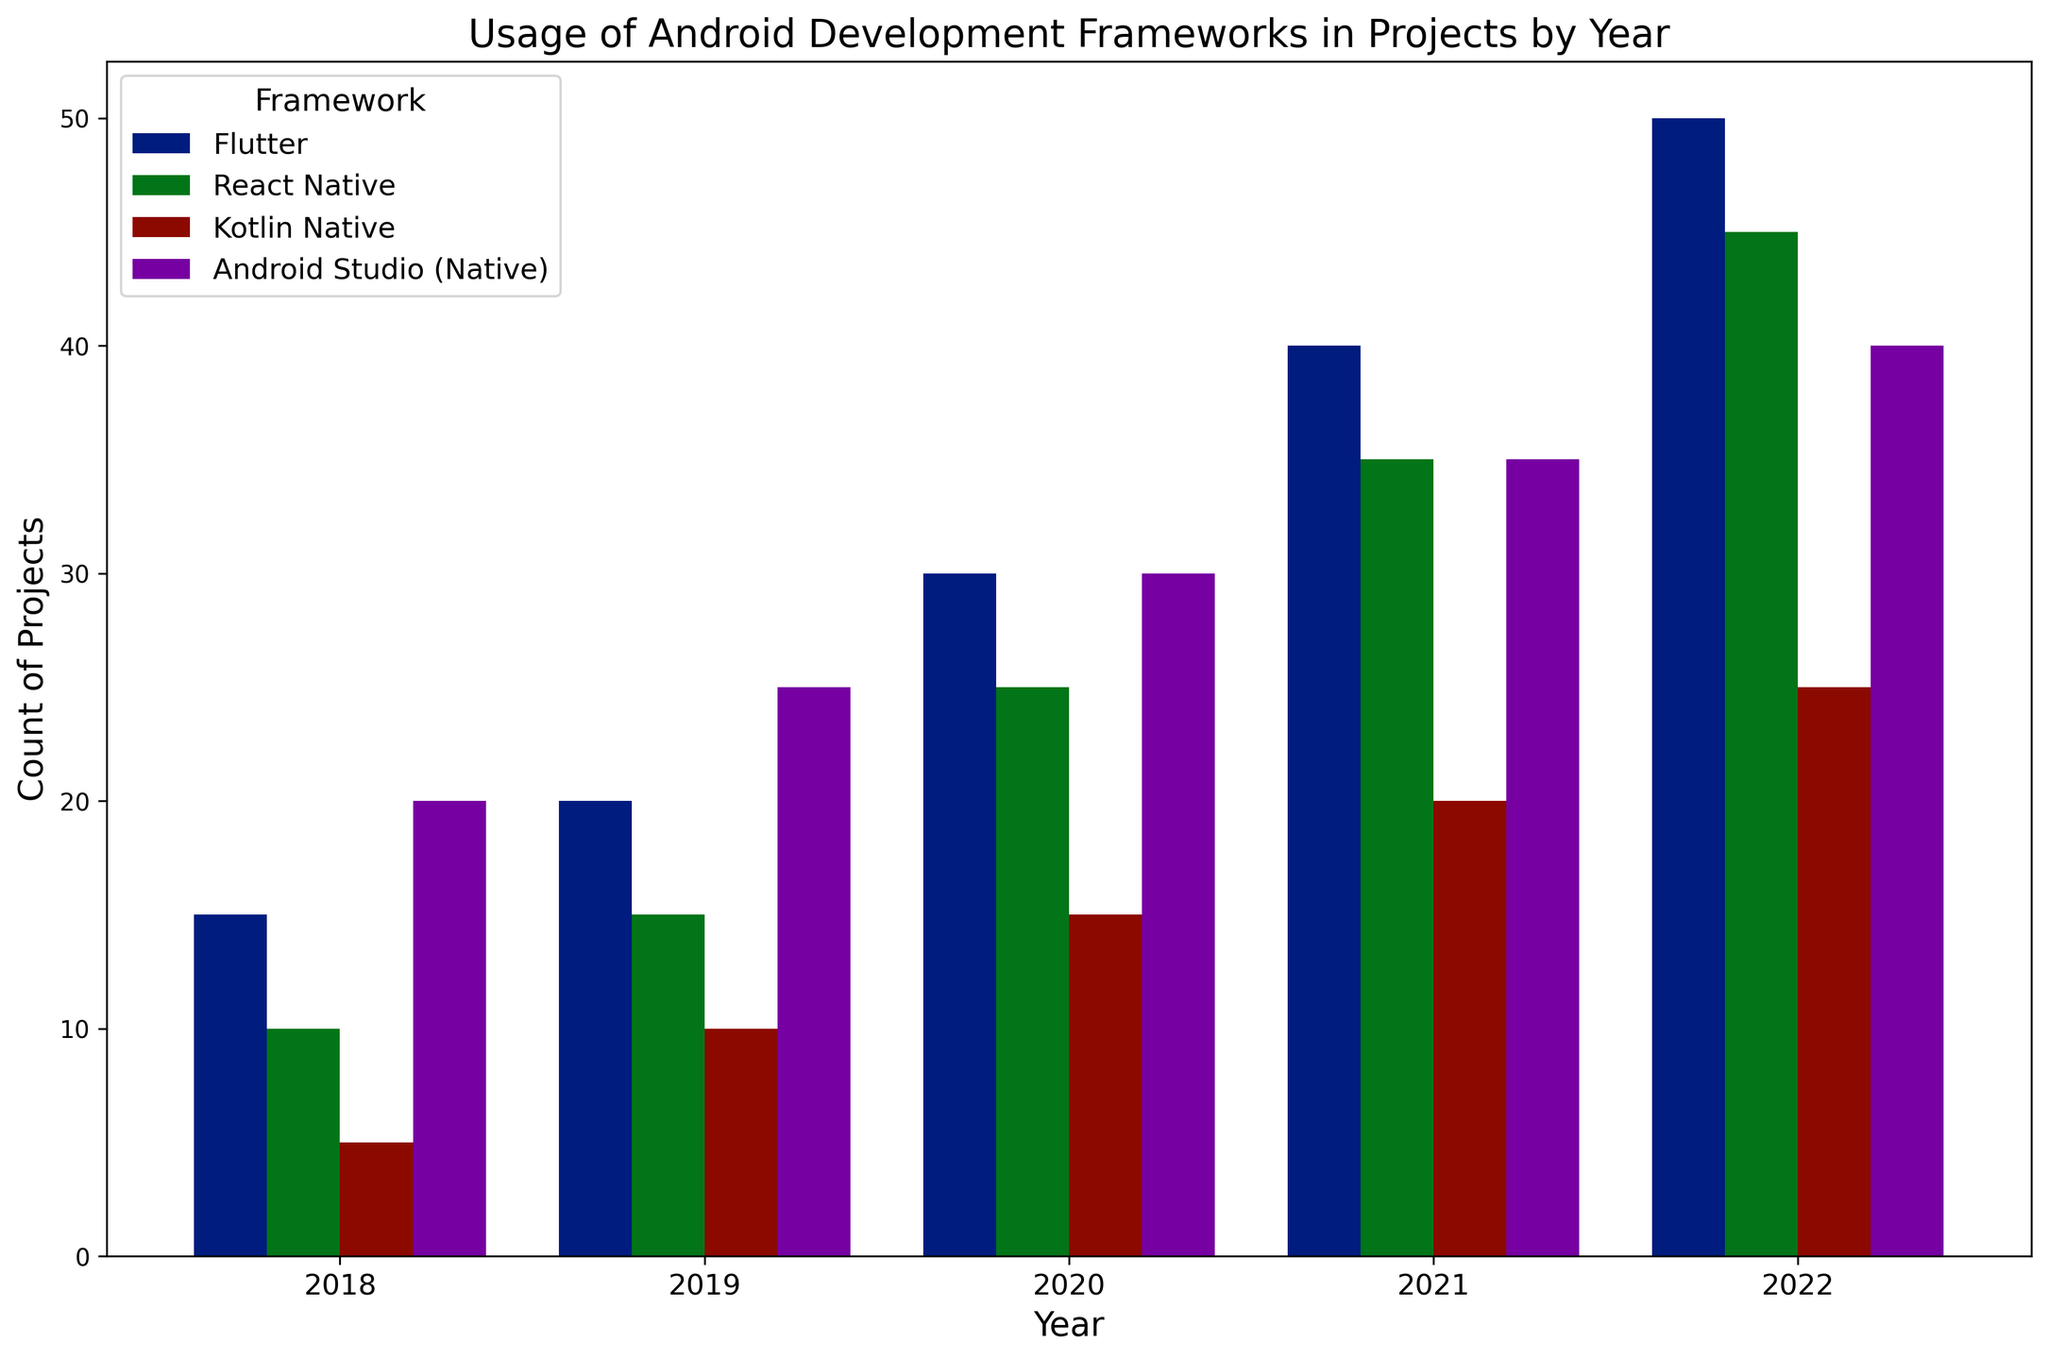How did the usage of Flutter change from 2018 to 2022? To find the change in usage, look at the height of the bars representing Flutter in 2018 and 2022. In 2018, it was 15 projects, and in 2022, it was 50 projects. Subtracting the 2018 value from the 2022 value gives the change: 50 - 15 = 35 projects.
Answer: It increased by 35 projects Which framework had the highest usage in 2021? Look at the 2021 bars and compare their heights. Flutter, with a bar height representing 40 projects, is the highest among the frameworks.
Answer: Flutter Compare the total usage of Kotlin Native and React Native in 2020. Which was higher and by how much? Find the heights of the bars for Kotlin Native and React Native in 2020. Kotlin Native was used in 15 projects, and React Native was used in 25 projects. Subtract the smaller value from the larger: 25 - 15 = 10 projects.
Answer: React Native was higher by 10 projects What is the average usage of Android Studio (Native) from 2018 to 2022? Add the values for Android Studio (Native) for each year: 20 + 25 + 30 + 35 + 40 = 150. Divide by the number of years: 150 / 5 = 30 projects.
Answer: 30 projects Compare the growth rates of Flutter and React Native from 2019 to 2022. Which grew faster? Calculate the growth for Flutter: 50 (2022) - 20 (2019) = 30 projects. Then calculate the growth for React Native: 45 (2022) - 15 (2019) = 30 projects. Both frameworks show the same growth of 30 projects.
Answer: Both grew by the same number of projects What was the least used framework in 2018, and how many projects used it? Compare the heights of the bars for 2018. Kotlin Native has the shortest bar, representing usage in 5 projects.
Answer: Kotlin Native with 5 projects Which framework saw the largest absolute increase in usage from 2020 to 2021? Calculate the difference in usage for each framework: 
- Flutter: 40 - 30 = 10, 
- React Native: 35 - 25 = 10, 
- Kotlin Native: 20 - 15 = 5, 
- Android Studio (Native): 35 - 30 = 5. 
Both Flutter and React Native saw the largest increase of 10 projects.
Answer: Flutter and React Native with 10 projects each In which year did React Native see its highest usage, and how many projects used it that year? Look at the bars representing React Native across all years and find the tallest one. In 2022, it reached its highest with 45 projects.
Answer: 2022 with 45 projects 